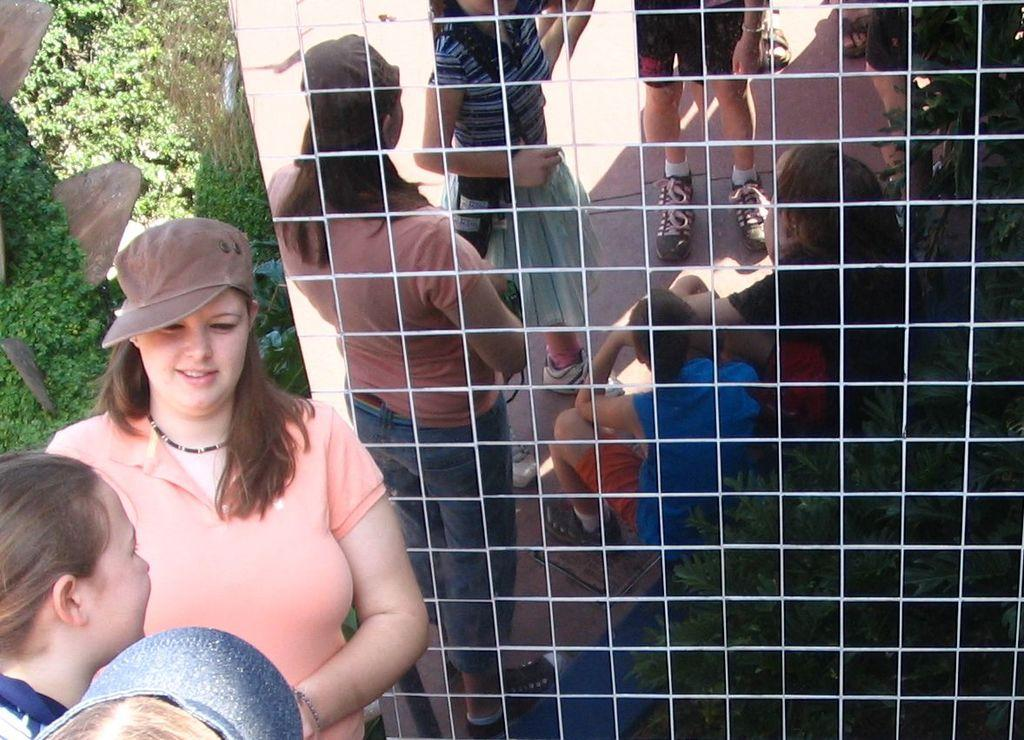How many people are present in the image? There are three persons standing in the image. What can be seen in the mirror's reflection? There is a reflection of a group of people and plants in the mirror. How does the fly contribute to the image? There is no fly present in the image. What emotion is displayed by the persons in the image? The provided facts do not mention any emotions or expressions of the persons in the image. 